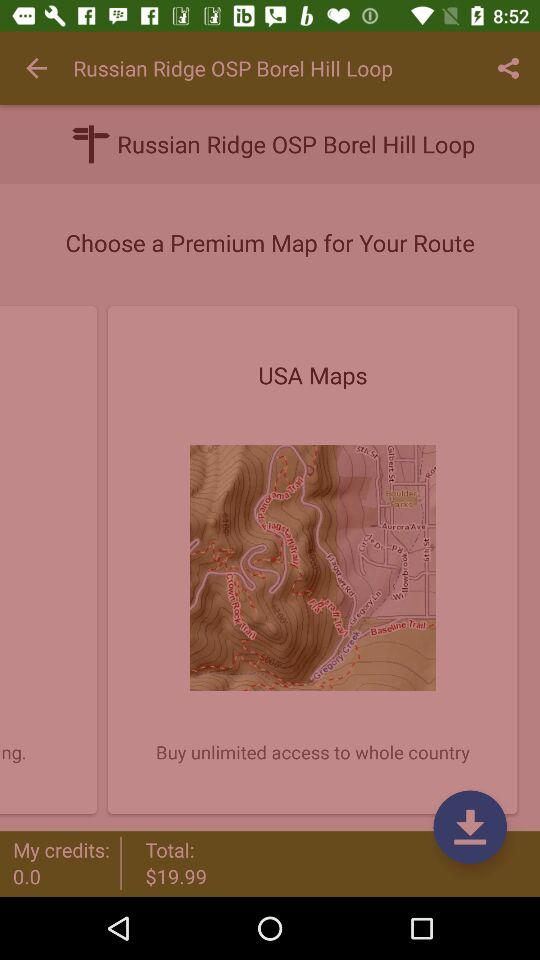What is the available amount in "My credits"? The available amount in "My credits" is 0. 